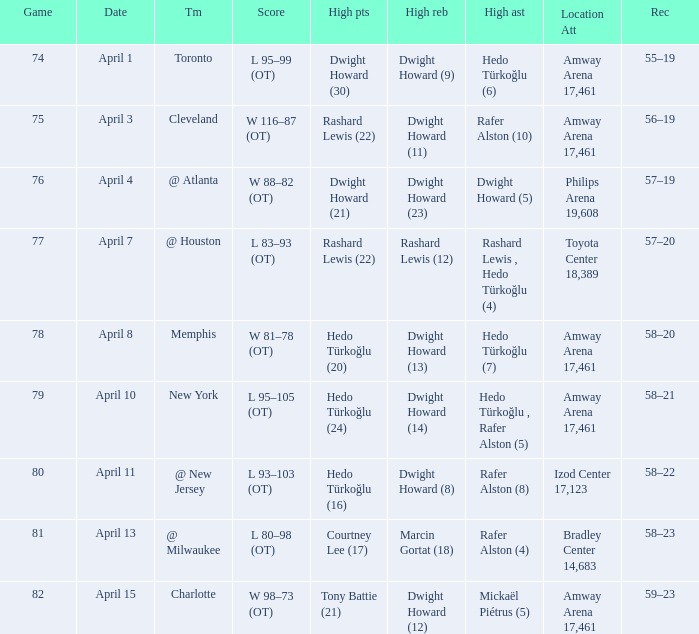What is the highest rebounds for game 81? Marcin Gortat (18). 